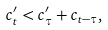Convert formula to latex. <formula><loc_0><loc_0><loc_500><loc_500>c ^ { \prime } _ { t } < c ^ { \prime } _ { \tau } + c _ { t - \tau } ,</formula> 